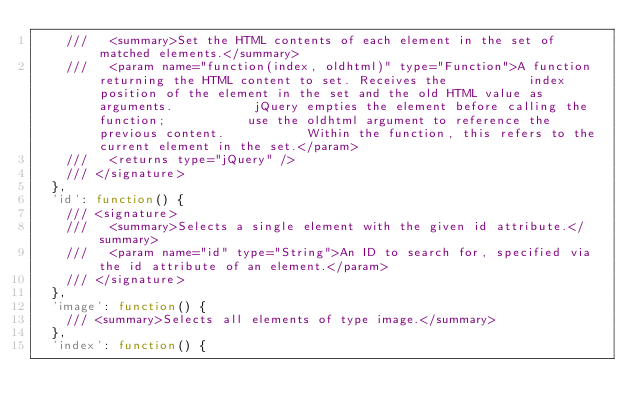Convert code to text. <code><loc_0><loc_0><loc_500><loc_500><_JavaScript_>    ///   <summary>Set the HTML contents of each element in the set of matched elements.</summary>
    ///   <param name="function(index, oldhtml)" type="Function">A function returning the HTML content to set. Receives the           index position of the element in the set and the old HTML value as arguments.           jQuery empties the element before calling the function;           use the oldhtml argument to reference the previous content.           Within the function, this refers to the current element in the set.</param>
    ///   <returns type="jQuery" />
    /// </signature>
  },
  'id': function() {
    /// <signature>
    ///   <summary>Selects a single element with the given id attribute.</summary>
    ///   <param name="id" type="String">An ID to search for, specified via the id attribute of an element.</param>
    /// </signature>
  },
  'image': function() {
    /// <summary>Selects all elements of type image.</summary>
  },
  'index': function() {</code> 